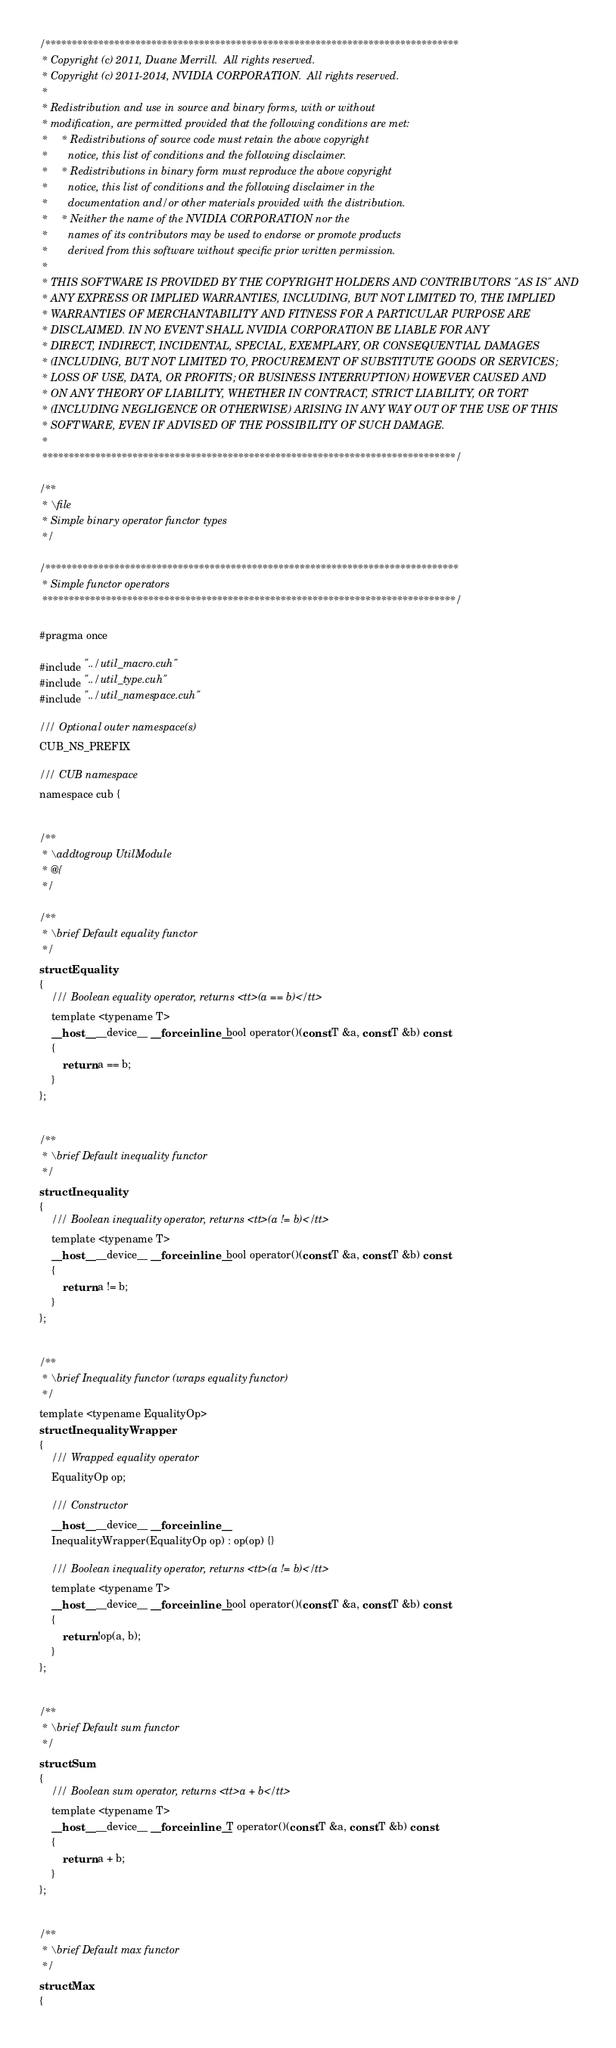Convert code to text. <code><loc_0><loc_0><loc_500><loc_500><_Cuda_>/******************************************************************************
 * Copyright (c) 2011, Duane Merrill.  All rights reserved.
 * Copyright (c) 2011-2014, NVIDIA CORPORATION.  All rights reserved.
 * 
 * Redistribution and use in source and binary forms, with or without
 * modification, are permitted provided that the following conditions are met:
 *     * Redistributions of source code must retain the above copyright
 *       notice, this list of conditions and the following disclaimer.
 *     * Redistributions in binary form must reproduce the above copyright
 *       notice, this list of conditions and the following disclaimer in the
 *       documentation and/or other materials provided with the distribution.
 *     * Neither the name of the NVIDIA CORPORATION nor the
 *       names of its contributors may be used to endorse or promote products
 *       derived from this software without specific prior written permission.
 * 
 * THIS SOFTWARE IS PROVIDED BY THE COPYRIGHT HOLDERS AND CONTRIBUTORS "AS IS" AND
 * ANY EXPRESS OR IMPLIED WARRANTIES, INCLUDING, BUT NOT LIMITED TO, THE IMPLIED
 * WARRANTIES OF MERCHANTABILITY AND FITNESS FOR A PARTICULAR PURPOSE ARE
 * DISCLAIMED. IN NO EVENT SHALL NVIDIA CORPORATION BE LIABLE FOR ANY
 * DIRECT, INDIRECT, INCIDENTAL, SPECIAL, EXEMPLARY, OR CONSEQUENTIAL DAMAGES
 * (INCLUDING, BUT NOT LIMITED TO, PROCUREMENT OF SUBSTITUTE GOODS OR SERVICES;
 * LOSS OF USE, DATA, OR PROFITS; OR BUSINESS INTERRUPTION) HOWEVER CAUSED AND
 * ON ANY THEORY OF LIABILITY, WHETHER IN CONTRACT, STRICT LIABILITY, OR TORT
 * (INCLUDING NEGLIGENCE OR OTHERWISE) ARISING IN ANY WAY OUT OF THE USE OF THIS
 * SOFTWARE, EVEN IF ADVISED OF THE POSSIBILITY OF SUCH DAMAGE.
 *
 ******************************************************************************/

/**
 * \file
 * Simple binary operator functor types
 */

/******************************************************************************
 * Simple functor operators
 ******************************************************************************/

#pragma once

#include "../util_macro.cuh"
#include "../util_type.cuh"
#include "../util_namespace.cuh"

/// Optional outer namespace(s)
CUB_NS_PREFIX

/// CUB namespace
namespace cub {


/**
 * \addtogroup UtilModule
 * @{
 */

/**
 * \brief Default equality functor
 */
struct Equality
{
    /// Boolean equality operator, returns <tt>(a == b)</tt>
    template <typename T>
    __host__ __device__ __forceinline__ bool operator()(const T &a, const T &b) const
    {
        return a == b;
    }
};


/**
 * \brief Default inequality functor
 */
struct Inequality
{
    /// Boolean inequality operator, returns <tt>(a != b)</tt>
    template <typename T>
    __host__ __device__ __forceinline__ bool operator()(const T &a, const T &b) const
    {
        return a != b;
    }
};


/**
 * \brief Inequality functor (wraps equality functor)
 */
template <typename EqualityOp>
struct InequalityWrapper
{
    /// Wrapped equality operator
    EqualityOp op;

    /// Constructor
    __host__ __device__ __forceinline__
    InequalityWrapper(EqualityOp op) : op(op) {}

    /// Boolean inequality operator, returns <tt>(a != b)</tt>
    template <typename T>
    __host__ __device__ __forceinline__ bool operator()(const T &a, const T &b) const
    {
        return !op(a, b);
    }
};


/**
 * \brief Default sum functor
 */
struct Sum
{
    /// Boolean sum operator, returns <tt>a + b</tt>
    template <typename T>
    __host__ __device__ __forceinline__ T operator()(const T &a, const T &b) const
    {
        return a + b;
    }
};


/**
 * \brief Default max functor
 */
struct Max
{</code> 